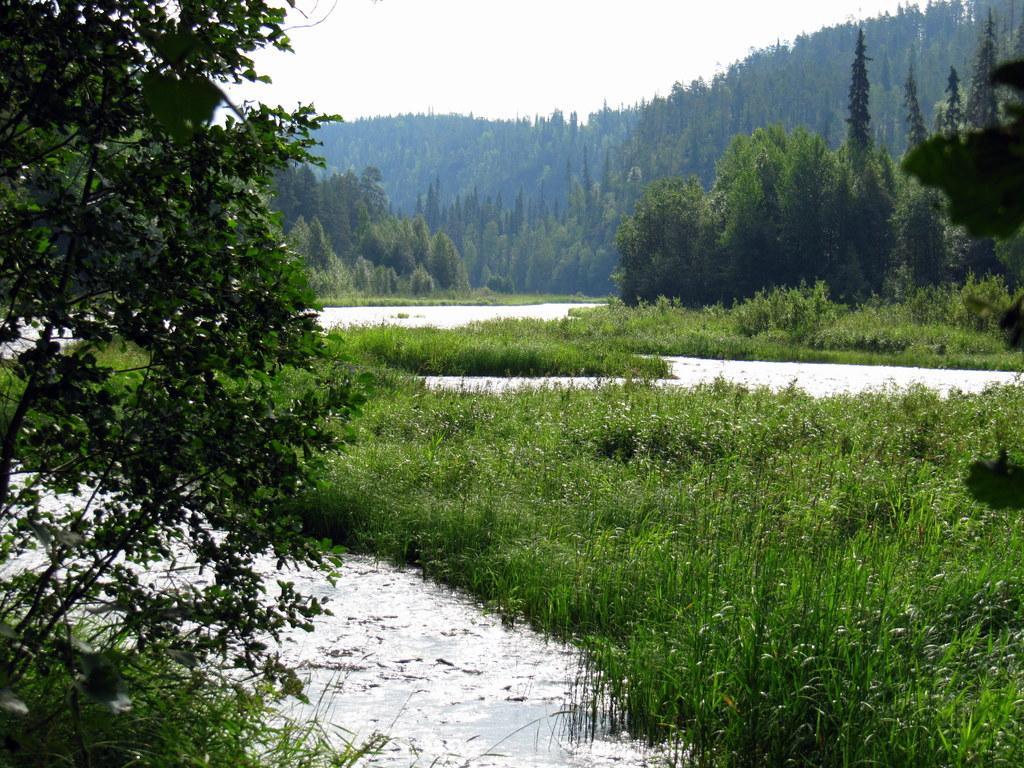What is one of the main elements in the image? There is water in the image. What type of vegetation can be seen in the image? There is grass, plants, and trees in the image. What can be seen in the distance in the image? In the background, there are mountains and more trees. What part of the natural environment is visible in the image? The sky is visible in the background. What year is depicted in the image? The image does not depict a specific year; it is a natural scene with no indication of time. 